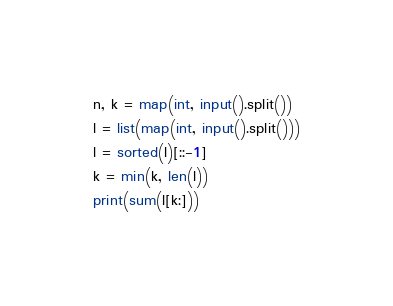Convert code to text. <code><loc_0><loc_0><loc_500><loc_500><_Python_>n, k = map(int, input().split())
l = list(map(int, input().split()))
l = sorted(l)[::-1]
k = min(k, len(l))
print(sum(l[k:]))</code> 